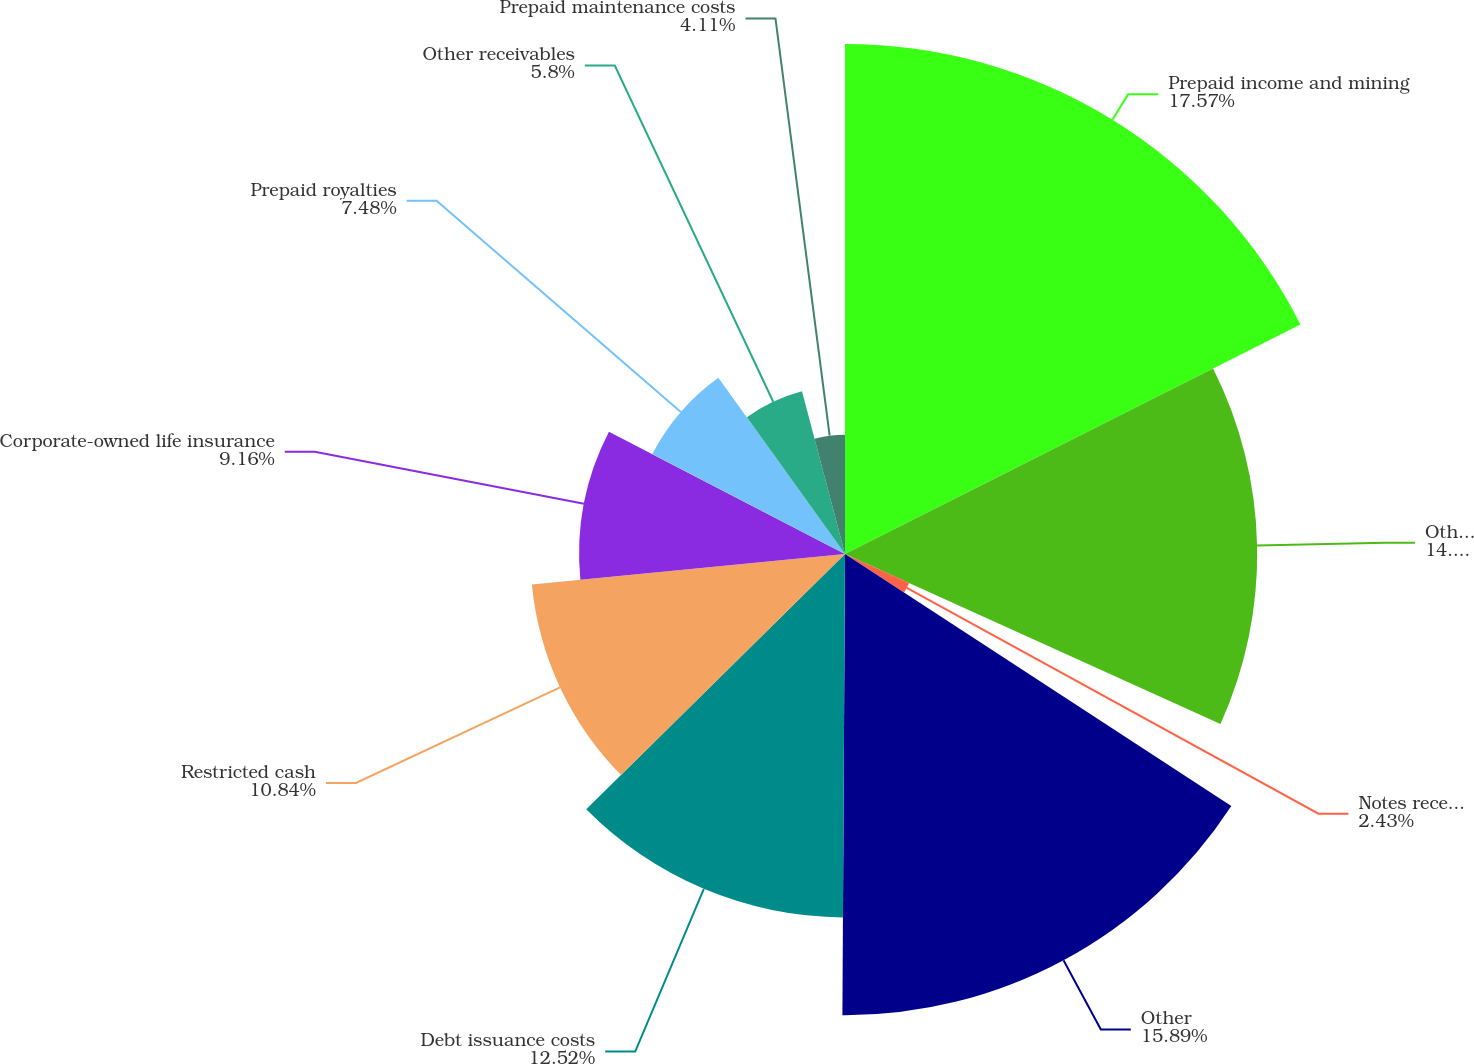Convert chart. <chart><loc_0><loc_0><loc_500><loc_500><pie_chart><fcel>Prepaid income and mining<fcel>Other prepaid assets<fcel>Notes receivable<fcel>Other<fcel>Debt issuance costs<fcel>Restricted cash<fcel>Corporate-owned life insurance<fcel>Prepaid royalties<fcel>Other receivables<fcel>Prepaid maintenance costs<nl><fcel>17.57%<fcel>14.2%<fcel>2.43%<fcel>15.89%<fcel>12.52%<fcel>10.84%<fcel>9.16%<fcel>7.48%<fcel>5.8%<fcel>4.11%<nl></chart> 